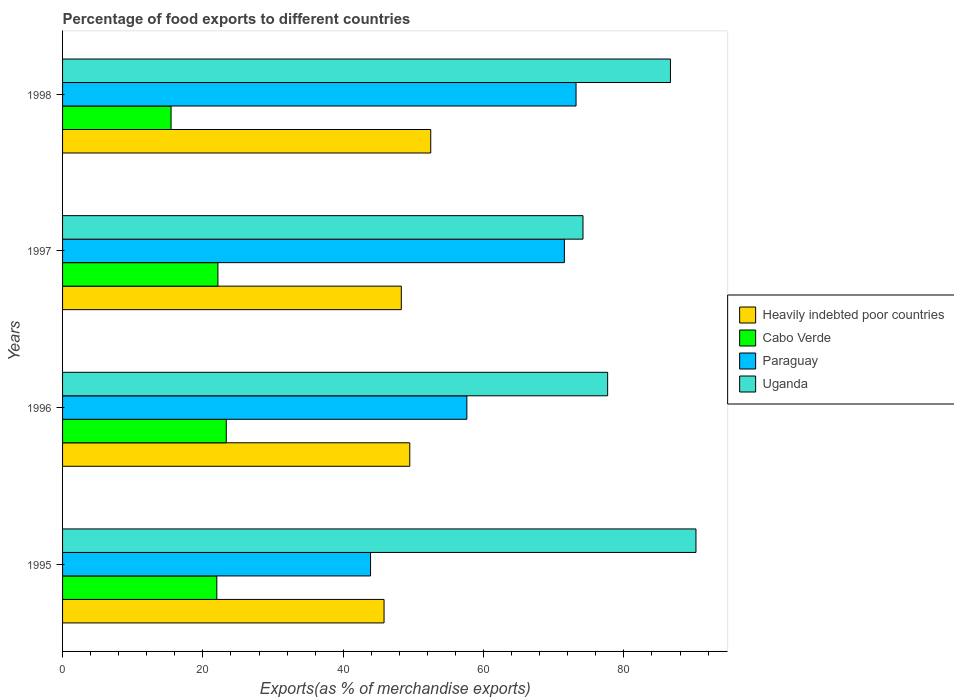How many different coloured bars are there?
Provide a succinct answer. 4. How many groups of bars are there?
Your answer should be compact. 4. Are the number of bars per tick equal to the number of legend labels?
Provide a short and direct response. Yes. How many bars are there on the 2nd tick from the top?
Give a very brief answer. 4. How many bars are there on the 2nd tick from the bottom?
Keep it short and to the point. 4. In how many cases, is the number of bars for a given year not equal to the number of legend labels?
Provide a succinct answer. 0. What is the percentage of exports to different countries in Uganda in 1996?
Your answer should be compact. 77.68. Across all years, what is the maximum percentage of exports to different countries in Cabo Verde?
Give a very brief answer. 23.33. Across all years, what is the minimum percentage of exports to different countries in Uganda?
Make the answer very short. 74.17. In which year was the percentage of exports to different countries in Paraguay maximum?
Provide a succinct answer. 1998. What is the total percentage of exports to different countries in Cabo Verde in the graph?
Offer a terse response. 82.92. What is the difference between the percentage of exports to different countries in Heavily indebted poor countries in 1996 and that in 1997?
Your response must be concise. 1.21. What is the difference between the percentage of exports to different countries in Heavily indebted poor countries in 1996 and the percentage of exports to different countries in Paraguay in 1997?
Your response must be concise. -22.03. What is the average percentage of exports to different countries in Uganda per year?
Your answer should be very brief. 82.19. In the year 1996, what is the difference between the percentage of exports to different countries in Uganda and percentage of exports to different countries in Cabo Verde?
Provide a short and direct response. 54.35. What is the ratio of the percentage of exports to different countries in Heavily indebted poor countries in 1996 to that in 1997?
Keep it short and to the point. 1.03. Is the percentage of exports to different countries in Uganda in 1995 less than that in 1998?
Your answer should be very brief. No. What is the difference between the highest and the second highest percentage of exports to different countries in Cabo Verde?
Ensure brevity in your answer.  1.19. What is the difference between the highest and the lowest percentage of exports to different countries in Paraguay?
Offer a terse response. 29.29. In how many years, is the percentage of exports to different countries in Cabo Verde greater than the average percentage of exports to different countries in Cabo Verde taken over all years?
Keep it short and to the point. 3. Is the sum of the percentage of exports to different countries in Cabo Verde in 1997 and 1998 greater than the maximum percentage of exports to different countries in Heavily indebted poor countries across all years?
Provide a short and direct response. No. What does the 3rd bar from the top in 1996 represents?
Make the answer very short. Cabo Verde. What does the 2nd bar from the bottom in 1995 represents?
Your answer should be very brief. Cabo Verde. How many bars are there?
Provide a succinct answer. 16. Are all the bars in the graph horizontal?
Offer a terse response. Yes. How many years are there in the graph?
Your answer should be compact. 4. Does the graph contain grids?
Give a very brief answer. No. Where does the legend appear in the graph?
Your response must be concise. Center right. What is the title of the graph?
Ensure brevity in your answer.  Percentage of food exports to different countries. What is the label or title of the X-axis?
Provide a short and direct response. Exports(as % of merchandise exports). What is the Exports(as % of merchandise exports) of Heavily indebted poor countries in 1995?
Offer a terse response. 45.82. What is the Exports(as % of merchandise exports) in Cabo Verde in 1995?
Keep it short and to the point. 21.99. What is the Exports(as % of merchandise exports) of Paraguay in 1995?
Keep it short and to the point. 43.89. What is the Exports(as % of merchandise exports) of Uganda in 1995?
Your answer should be compact. 90.27. What is the Exports(as % of merchandise exports) of Heavily indebted poor countries in 1996?
Keep it short and to the point. 49.49. What is the Exports(as % of merchandise exports) of Cabo Verde in 1996?
Your answer should be compact. 23.33. What is the Exports(as % of merchandise exports) in Paraguay in 1996?
Offer a very short reply. 57.62. What is the Exports(as % of merchandise exports) in Uganda in 1996?
Provide a short and direct response. 77.68. What is the Exports(as % of merchandise exports) of Heavily indebted poor countries in 1997?
Offer a terse response. 48.28. What is the Exports(as % of merchandise exports) in Cabo Verde in 1997?
Your response must be concise. 22.14. What is the Exports(as % of merchandise exports) in Paraguay in 1997?
Provide a succinct answer. 71.52. What is the Exports(as % of merchandise exports) in Uganda in 1997?
Give a very brief answer. 74.17. What is the Exports(as % of merchandise exports) in Heavily indebted poor countries in 1998?
Offer a very short reply. 52.47. What is the Exports(as % of merchandise exports) in Cabo Verde in 1998?
Your answer should be very brief. 15.46. What is the Exports(as % of merchandise exports) of Paraguay in 1998?
Provide a succinct answer. 73.18. What is the Exports(as % of merchandise exports) in Uganda in 1998?
Your answer should be compact. 86.64. Across all years, what is the maximum Exports(as % of merchandise exports) of Heavily indebted poor countries?
Your answer should be compact. 52.47. Across all years, what is the maximum Exports(as % of merchandise exports) in Cabo Verde?
Your answer should be compact. 23.33. Across all years, what is the maximum Exports(as % of merchandise exports) of Paraguay?
Ensure brevity in your answer.  73.18. Across all years, what is the maximum Exports(as % of merchandise exports) in Uganda?
Give a very brief answer. 90.27. Across all years, what is the minimum Exports(as % of merchandise exports) in Heavily indebted poor countries?
Keep it short and to the point. 45.82. Across all years, what is the minimum Exports(as % of merchandise exports) in Cabo Verde?
Ensure brevity in your answer.  15.46. Across all years, what is the minimum Exports(as % of merchandise exports) of Paraguay?
Your response must be concise. 43.89. Across all years, what is the minimum Exports(as % of merchandise exports) in Uganda?
Provide a short and direct response. 74.17. What is the total Exports(as % of merchandise exports) in Heavily indebted poor countries in the graph?
Your response must be concise. 196.05. What is the total Exports(as % of merchandise exports) in Cabo Verde in the graph?
Give a very brief answer. 82.92. What is the total Exports(as % of merchandise exports) of Paraguay in the graph?
Offer a terse response. 246.22. What is the total Exports(as % of merchandise exports) of Uganda in the graph?
Ensure brevity in your answer.  328.77. What is the difference between the Exports(as % of merchandise exports) of Heavily indebted poor countries in 1995 and that in 1996?
Make the answer very short. -3.67. What is the difference between the Exports(as % of merchandise exports) of Cabo Verde in 1995 and that in 1996?
Keep it short and to the point. -1.35. What is the difference between the Exports(as % of merchandise exports) of Paraguay in 1995 and that in 1996?
Give a very brief answer. -13.73. What is the difference between the Exports(as % of merchandise exports) of Uganda in 1995 and that in 1996?
Keep it short and to the point. 12.59. What is the difference between the Exports(as % of merchandise exports) of Heavily indebted poor countries in 1995 and that in 1997?
Offer a terse response. -2.46. What is the difference between the Exports(as % of merchandise exports) of Cabo Verde in 1995 and that in 1997?
Offer a terse response. -0.16. What is the difference between the Exports(as % of merchandise exports) of Paraguay in 1995 and that in 1997?
Offer a very short reply. -27.62. What is the difference between the Exports(as % of merchandise exports) of Uganda in 1995 and that in 1997?
Provide a succinct answer. 16.1. What is the difference between the Exports(as % of merchandise exports) of Heavily indebted poor countries in 1995 and that in 1998?
Give a very brief answer. -6.65. What is the difference between the Exports(as % of merchandise exports) of Cabo Verde in 1995 and that in 1998?
Your answer should be compact. 6.52. What is the difference between the Exports(as % of merchandise exports) in Paraguay in 1995 and that in 1998?
Your answer should be very brief. -29.29. What is the difference between the Exports(as % of merchandise exports) in Uganda in 1995 and that in 1998?
Ensure brevity in your answer.  3.64. What is the difference between the Exports(as % of merchandise exports) of Heavily indebted poor countries in 1996 and that in 1997?
Keep it short and to the point. 1.21. What is the difference between the Exports(as % of merchandise exports) in Cabo Verde in 1996 and that in 1997?
Offer a terse response. 1.19. What is the difference between the Exports(as % of merchandise exports) in Paraguay in 1996 and that in 1997?
Give a very brief answer. -13.9. What is the difference between the Exports(as % of merchandise exports) of Uganda in 1996 and that in 1997?
Provide a succinct answer. 3.51. What is the difference between the Exports(as % of merchandise exports) of Heavily indebted poor countries in 1996 and that in 1998?
Ensure brevity in your answer.  -2.99. What is the difference between the Exports(as % of merchandise exports) of Cabo Verde in 1996 and that in 1998?
Your answer should be compact. 7.87. What is the difference between the Exports(as % of merchandise exports) of Paraguay in 1996 and that in 1998?
Your response must be concise. -15.56. What is the difference between the Exports(as % of merchandise exports) of Uganda in 1996 and that in 1998?
Offer a terse response. -8.95. What is the difference between the Exports(as % of merchandise exports) in Heavily indebted poor countries in 1997 and that in 1998?
Ensure brevity in your answer.  -4.2. What is the difference between the Exports(as % of merchandise exports) in Cabo Verde in 1997 and that in 1998?
Your answer should be very brief. 6.68. What is the difference between the Exports(as % of merchandise exports) in Paraguay in 1997 and that in 1998?
Provide a short and direct response. -1.66. What is the difference between the Exports(as % of merchandise exports) in Uganda in 1997 and that in 1998?
Offer a very short reply. -12.46. What is the difference between the Exports(as % of merchandise exports) of Heavily indebted poor countries in 1995 and the Exports(as % of merchandise exports) of Cabo Verde in 1996?
Offer a very short reply. 22.49. What is the difference between the Exports(as % of merchandise exports) in Heavily indebted poor countries in 1995 and the Exports(as % of merchandise exports) in Paraguay in 1996?
Your answer should be compact. -11.8. What is the difference between the Exports(as % of merchandise exports) of Heavily indebted poor countries in 1995 and the Exports(as % of merchandise exports) of Uganda in 1996?
Provide a succinct answer. -31.87. What is the difference between the Exports(as % of merchandise exports) of Cabo Verde in 1995 and the Exports(as % of merchandise exports) of Paraguay in 1996?
Provide a succinct answer. -35.64. What is the difference between the Exports(as % of merchandise exports) of Cabo Verde in 1995 and the Exports(as % of merchandise exports) of Uganda in 1996?
Provide a succinct answer. -55.7. What is the difference between the Exports(as % of merchandise exports) of Paraguay in 1995 and the Exports(as % of merchandise exports) of Uganda in 1996?
Offer a very short reply. -33.79. What is the difference between the Exports(as % of merchandise exports) in Heavily indebted poor countries in 1995 and the Exports(as % of merchandise exports) in Cabo Verde in 1997?
Your answer should be very brief. 23.68. What is the difference between the Exports(as % of merchandise exports) of Heavily indebted poor countries in 1995 and the Exports(as % of merchandise exports) of Paraguay in 1997?
Provide a succinct answer. -25.7. What is the difference between the Exports(as % of merchandise exports) in Heavily indebted poor countries in 1995 and the Exports(as % of merchandise exports) in Uganda in 1997?
Offer a very short reply. -28.35. What is the difference between the Exports(as % of merchandise exports) of Cabo Verde in 1995 and the Exports(as % of merchandise exports) of Paraguay in 1997?
Make the answer very short. -49.53. What is the difference between the Exports(as % of merchandise exports) in Cabo Verde in 1995 and the Exports(as % of merchandise exports) in Uganda in 1997?
Provide a short and direct response. -52.19. What is the difference between the Exports(as % of merchandise exports) in Paraguay in 1995 and the Exports(as % of merchandise exports) in Uganda in 1997?
Provide a short and direct response. -30.28. What is the difference between the Exports(as % of merchandise exports) in Heavily indebted poor countries in 1995 and the Exports(as % of merchandise exports) in Cabo Verde in 1998?
Ensure brevity in your answer.  30.35. What is the difference between the Exports(as % of merchandise exports) of Heavily indebted poor countries in 1995 and the Exports(as % of merchandise exports) of Paraguay in 1998?
Your response must be concise. -27.36. What is the difference between the Exports(as % of merchandise exports) of Heavily indebted poor countries in 1995 and the Exports(as % of merchandise exports) of Uganda in 1998?
Give a very brief answer. -40.82. What is the difference between the Exports(as % of merchandise exports) in Cabo Verde in 1995 and the Exports(as % of merchandise exports) in Paraguay in 1998?
Provide a short and direct response. -51.2. What is the difference between the Exports(as % of merchandise exports) of Cabo Verde in 1995 and the Exports(as % of merchandise exports) of Uganda in 1998?
Keep it short and to the point. -64.65. What is the difference between the Exports(as % of merchandise exports) of Paraguay in 1995 and the Exports(as % of merchandise exports) of Uganda in 1998?
Make the answer very short. -42.74. What is the difference between the Exports(as % of merchandise exports) of Heavily indebted poor countries in 1996 and the Exports(as % of merchandise exports) of Cabo Verde in 1997?
Make the answer very short. 27.34. What is the difference between the Exports(as % of merchandise exports) in Heavily indebted poor countries in 1996 and the Exports(as % of merchandise exports) in Paraguay in 1997?
Your answer should be compact. -22.03. What is the difference between the Exports(as % of merchandise exports) of Heavily indebted poor countries in 1996 and the Exports(as % of merchandise exports) of Uganda in 1997?
Your response must be concise. -24.69. What is the difference between the Exports(as % of merchandise exports) of Cabo Verde in 1996 and the Exports(as % of merchandise exports) of Paraguay in 1997?
Provide a short and direct response. -48.19. What is the difference between the Exports(as % of merchandise exports) of Cabo Verde in 1996 and the Exports(as % of merchandise exports) of Uganda in 1997?
Offer a terse response. -50.84. What is the difference between the Exports(as % of merchandise exports) in Paraguay in 1996 and the Exports(as % of merchandise exports) in Uganda in 1997?
Offer a terse response. -16.55. What is the difference between the Exports(as % of merchandise exports) of Heavily indebted poor countries in 1996 and the Exports(as % of merchandise exports) of Cabo Verde in 1998?
Make the answer very short. 34.02. What is the difference between the Exports(as % of merchandise exports) in Heavily indebted poor countries in 1996 and the Exports(as % of merchandise exports) in Paraguay in 1998?
Give a very brief answer. -23.7. What is the difference between the Exports(as % of merchandise exports) of Heavily indebted poor countries in 1996 and the Exports(as % of merchandise exports) of Uganda in 1998?
Your answer should be compact. -37.15. What is the difference between the Exports(as % of merchandise exports) of Cabo Verde in 1996 and the Exports(as % of merchandise exports) of Paraguay in 1998?
Ensure brevity in your answer.  -49.85. What is the difference between the Exports(as % of merchandise exports) in Cabo Verde in 1996 and the Exports(as % of merchandise exports) in Uganda in 1998?
Provide a succinct answer. -63.31. What is the difference between the Exports(as % of merchandise exports) of Paraguay in 1996 and the Exports(as % of merchandise exports) of Uganda in 1998?
Offer a very short reply. -29.02. What is the difference between the Exports(as % of merchandise exports) of Heavily indebted poor countries in 1997 and the Exports(as % of merchandise exports) of Cabo Verde in 1998?
Your response must be concise. 32.81. What is the difference between the Exports(as % of merchandise exports) in Heavily indebted poor countries in 1997 and the Exports(as % of merchandise exports) in Paraguay in 1998?
Keep it short and to the point. -24.91. What is the difference between the Exports(as % of merchandise exports) of Heavily indebted poor countries in 1997 and the Exports(as % of merchandise exports) of Uganda in 1998?
Your answer should be very brief. -38.36. What is the difference between the Exports(as % of merchandise exports) in Cabo Verde in 1997 and the Exports(as % of merchandise exports) in Paraguay in 1998?
Your response must be concise. -51.04. What is the difference between the Exports(as % of merchandise exports) of Cabo Verde in 1997 and the Exports(as % of merchandise exports) of Uganda in 1998?
Provide a short and direct response. -64.5. What is the difference between the Exports(as % of merchandise exports) of Paraguay in 1997 and the Exports(as % of merchandise exports) of Uganda in 1998?
Keep it short and to the point. -15.12. What is the average Exports(as % of merchandise exports) of Heavily indebted poor countries per year?
Provide a short and direct response. 49.01. What is the average Exports(as % of merchandise exports) of Cabo Verde per year?
Make the answer very short. 20.73. What is the average Exports(as % of merchandise exports) of Paraguay per year?
Give a very brief answer. 61.55. What is the average Exports(as % of merchandise exports) in Uganda per year?
Your answer should be very brief. 82.19. In the year 1995, what is the difference between the Exports(as % of merchandise exports) of Heavily indebted poor countries and Exports(as % of merchandise exports) of Cabo Verde?
Your answer should be very brief. 23.83. In the year 1995, what is the difference between the Exports(as % of merchandise exports) of Heavily indebted poor countries and Exports(as % of merchandise exports) of Paraguay?
Offer a terse response. 1.92. In the year 1995, what is the difference between the Exports(as % of merchandise exports) in Heavily indebted poor countries and Exports(as % of merchandise exports) in Uganda?
Offer a very short reply. -44.46. In the year 1995, what is the difference between the Exports(as % of merchandise exports) in Cabo Verde and Exports(as % of merchandise exports) in Paraguay?
Provide a short and direct response. -21.91. In the year 1995, what is the difference between the Exports(as % of merchandise exports) in Cabo Verde and Exports(as % of merchandise exports) in Uganda?
Your answer should be compact. -68.29. In the year 1995, what is the difference between the Exports(as % of merchandise exports) in Paraguay and Exports(as % of merchandise exports) in Uganda?
Offer a very short reply. -46.38. In the year 1996, what is the difference between the Exports(as % of merchandise exports) in Heavily indebted poor countries and Exports(as % of merchandise exports) in Cabo Verde?
Ensure brevity in your answer.  26.15. In the year 1996, what is the difference between the Exports(as % of merchandise exports) in Heavily indebted poor countries and Exports(as % of merchandise exports) in Paraguay?
Your answer should be compact. -8.14. In the year 1996, what is the difference between the Exports(as % of merchandise exports) of Heavily indebted poor countries and Exports(as % of merchandise exports) of Uganda?
Offer a very short reply. -28.2. In the year 1996, what is the difference between the Exports(as % of merchandise exports) of Cabo Verde and Exports(as % of merchandise exports) of Paraguay?
Your answer should be very brief. -34.29. In the year 1996, what is the difference between the Exports(as % of merchandise exports) of Cabo Verde and Exports(as % of merchandise exports) of Uganda?
Your response must be concise. -54.35. In the year 1996, what is the difference between the Exports(as % of merchandise exports) in Paraguay and Exports(as % of merchandise exports) in Uganda?
Your answer should be compact. -20.06. In the year 1997, what is the difference between the Exports(as % of merchandise exports) of Heavily indebted poor countries and Exports(as % of merchandise exports) of Cabo Verde?
Give a very brief answer. 26.13. In the year 1997, what is the difference between the Exports(as % of merchandise exports) in Heavily indebted poor countries and Exports(as % of merchandise exports) in Paraguay?
Keep it short and to the point. -23.24. In the year 1997, what is the difference between the Exports(as % of merchandise exports) in Heavily indebted poor countries and Exports(as % of merchandise exports) in Uganda?
Your answer should be very brief. -25.9. In the year 1997, what is the difference between the Exports(as % of merchandise exports) in Cabo Verde and Exports(as % of merchandise exports) in Paraguay?
Your answer should be compact. -49.38. In the year 1997, what is the difference between the Exports(as % of merchandise exports) in Cabo Verde and Exports(as % of merchandise exports) in Uganda?
Offer a very short reply. -52.03. In the year 1997, what is the difference between the Exports(as % of merchandise exports) in Paraguay and Exports(as % of merchandise exports) in Uganda?
Make the answer very short. -2.66. In the year 1998, what is the difference between the Exports(as % of merchandise exports) of Heavily indebted poor countries and Exports(as % of merchandise exports) of Cabo Verde?
Provide a succinct answer. 37.01. In the year 1998, what is the difference between the Exports(as % of merchandise exports) of Heavily indebted poor countries and Exports(as % of merchandise exports) of Paraguay?
Keep it short and to the point. -20.71. In the year 1998, what is the difference between the Exports(as % of merchandise exports) in Heavily indebted poor countries and Exports(as % of merchandise exports) in Uganda?
Give a very brief answer. -34.17. In the year 1998, what is the difference between the Exports(as % of merchandise exports) of Cabo Verde and Exports(as % of merchandise exports) of Paraguay?
Provide a short and direct response. -57.72. In the year 1998, what is the difference between the Exports(as % of merchandise exports) of Cabo Verde and Exports(as % of merchandise exports) of Uganda?
Offer a terse response. -71.17. In the year 1998, what is the difference between the Exports(as % of merchandise exports) in Paraguay and Exports(as % of merchandise exports) in Uganda?
Offer a terse response. -13.46. What is the ratio of the Exports(as % of merchandise exports) in Heavily indebted poor countries in 1995 to that in 1996?
Your answer should be compact. 0.93. What is the ratio of the Exports(as % of merchandise exports) in Cabo Verde in 1995 to that in 1996?
Make the answer very short. 0.94. What is the ratio of the Exports(as % of merchandise exports) in Paraguay in 1995 to that in 1996?
Offer a terse response. 0.76. What is the ratio of the Exports(as % of merchandise exports) of Uganda in 1995 to that in 1996?
Offer a terse response. 1.16. What is the ratio of the Exports(as % of merchandise exports) in Heavily indebted poor countries in 1995 to that in 1997?
Provide a succinct answer. 0.95. What is the ratio of the Exports(as % of merchandise exports) of Paraguay in 1995 to that in 1997?
Your response must be concise. 0.61. What is the ratio of the Exports(as % of merchandise exports) in Uganda in 1995 to that in 1997?
Your answer should be compact. 1.22. What is the ratio of the Exports(as % of merchandise exports) of Heavily indebted poor countries in 1995 to that in 1998?
Ensure brevity in your answer.  0.87. What is the ratio of the Exports(as % of merchandise exports) of Cabo Verde in 1995 to that in 1998?
Ensure brevity in your answer.  1.42. What is the ratio of the Exports(as % of merchandise exports) of Paraguay in 1995 to that in 1998?
Provide a succinct answer. 0.6. What is the ratio of the Exports(as % of merchandise exports) in Uganda in 1995 to that in 1998?
Provide a succinct answer. 1.04. What is the ratio of the Exports(as % of merchandise exports) of Heavily indebted poor countries in 1996 to that in 1997?
Offer a terse response. 1.03. What is the ratio of the Exports(as % of merchandise exports) of Cabo Verde in 1996 to that in 1997?
Offer a very short reply. 1.05. What is the ratio of the Exports(as % of merchandise exports) of Paraguay in 1996 to that in 1997?
Ensure brevity in your answer.  0.81. What is the ratio of the Exports(as % of merchandise exports) of Uganda in 1996 to that in 1997?
Give a very brief answer. 1.05. What is the ratio of the Exports(as % of merchandise exports) of Heavily indebted poor countries in 1996 to that in 1998?
Provide a succinct answer. 0.94. What is the ratio of the Exports(as % of merchandise exports) of Cabo Verde in 1996 to that in 1998?
Offer a very short reply. 1.51. What is the ratio of the Exports(as % of merchandise exports) of Paraguay in 1996 to that in 1998?
Your answer should be compact. 0.79. What is the ratio of the Exports(as % of merchandise exports) of Uganda in 1996 to that in 1998?
Your answer should be compact. 0.9. What is the ratio of the Exports(as % of merchandise exports) in Heavily indebted poor countries in 1997 to that in 1998?
Your response must be concise. 0.92. What is the ratio of the Exports(as % of merchandise exports) of Cabo Verde in 1997 to that in 1998?
Keep it short and to the point. 1.43. What is the ratio of the Exports(as % of merchandise exports) in Paraguay in 1997 to that in 1998?
Provide a short and direct response. 0.98. What is the ratio of the Exports(as % of merchandise exports) of Uganda in 1997 to that in 1998?
Your response must be concise. 0.86. What is the difference between the highest and the second highest Exports(as % of merchandise exports) in Heavily indebted poor countries?
Provide a succinct answer. 2.99. What is the difference between the highest and the second highest Exports(as % of merchandise exports) of Cabo Verde?
Make the answer very short. 1.19. What is the difference between the highest and the second highest Exports(as % of merchandise exports) in Paraguay?
Your answer should be compact. 1.66. What is the difference between the highest and the second highest Exports(as % of merchandise exports) in Uganda?
Your answer should be very brief. 3.64. What is the difference between the highest and the lowest Exports(as % of merchandise exports) in Heavily indebted poor countries?
Make the answer very short. 6.65. What is the difference between the highest and the lowest Exports(as % of merchandise exports) in Cabo Verde?
Provide a short and direct response. 7.87. What is the difference between the highest and the lowest Exports(as % of merchandise exports) of Paraguay?
Your response must be concise. 29.29. What is the difference between the highest and the lowest Exports(as % of merchandise exports) in Uganda?
Your answer should be compact. 16.1. 